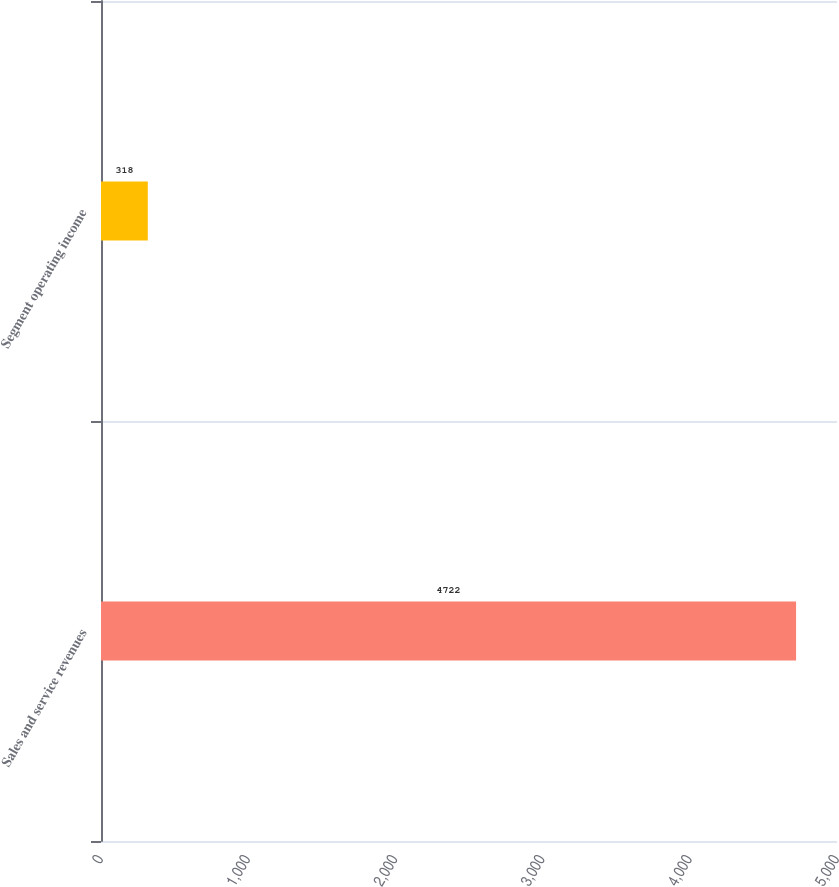Convert chart to OTSL. <chart><loc_0><loc_0><loc_500><loc_500><bar_chart><fcel>Sales and service revenues<fcel>Segment operating income<nl><fcel>4722<fcel>318<nl></chart> 